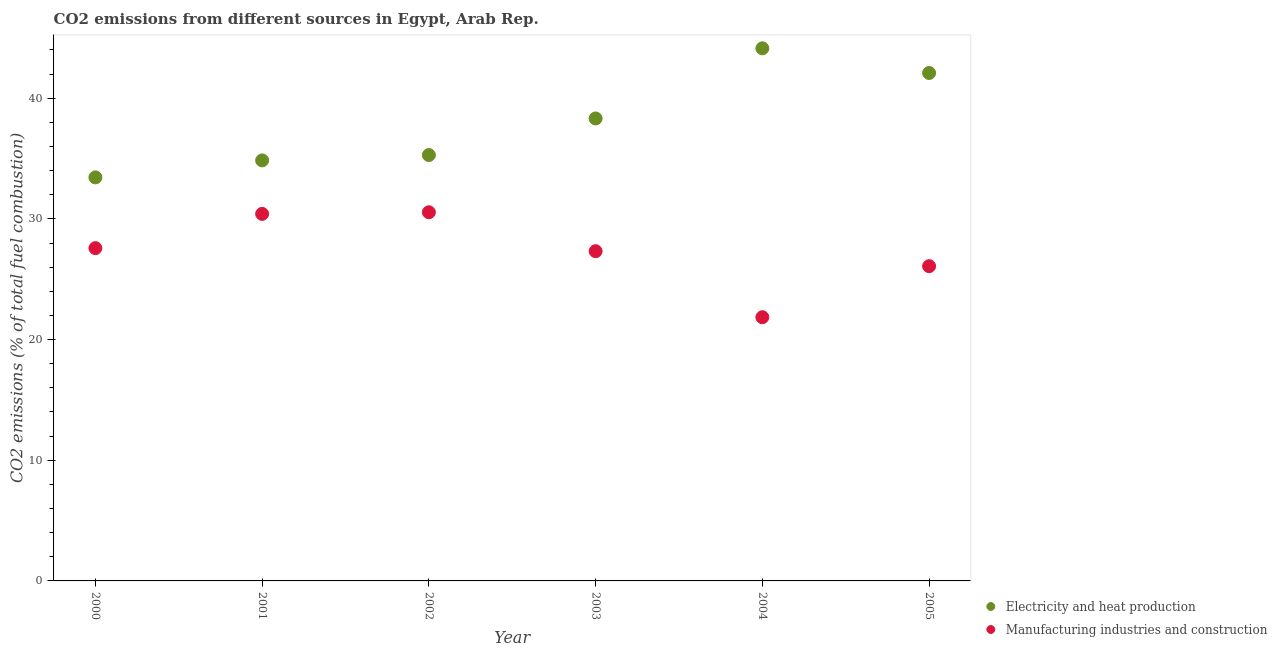Is the number of dotlines equal to the number of legend labels?
Your response must be concise. Yes. What is the co2 emissions due to manufacturing industries in 2005?
Keep it short and to the point. 26.08. Across all years, what is the maximum co2 emissions due to electricity and heat production?
Offer a terse response. 44.14. Across all years, what is the minimum co2 emissions due to electricity and heat production?
Offer a very short reply. 33.44. What is the total co2 emissions due to manufacturing industries in the graph?
Provide a succinct answer. 163.8. What is the difference between the co2 emissions due to electricity and heat production in 2000 and that in 2005?
Ensure brevity in your answer.  -8.65. What is the difference between the co2 emissions due to manufacturing industries in 2003 and the co2 emissions due to electricity and heat production in 2005?
Your response must be concise. -14.77. What is the average co2 emissions due to manufacturing industries per year?
Provide a short and direct response. 27.3. In the year 2001, what is the difference between the co2 emissions due to manufacturing industries and co2 emissions due to electricity and heat production?
Your response must be concise. -4.43. What is the ratio of the co2 emissions due to electricity and heat production in 2003 to that in 2004?
Offer a terse response. 0.87. What is the difference between the highest and the second highest co2 emissions due to manufacturing industries?
Give a very brief answer. 0.13. What is the difference between the highest and the lowest co2 emissions due to electricity and heat production?
Your response must be concise. 10.7. In how many years, is the co2 emissions due to manufacturing industries greater than the average co2 emissions due to manufacturing industries taken over all years?
Give a very brief answer. 4. Is the sum of the co2 emissions due to electricity and heat production in 2000 and 2005 greater than the maximum co2 emissions due to manufacturing industries across all years?
Provide a succinct answer. Yes. How many dotlines are there?
Your answer should be compact. 2. How many years are there in the graph?
Ensure brevity in your answer.  6. Are the values on the major ticks of Y-axis written in scientific E-notation?
Keep it short and to the point. No. What is the title of the graph?
Offer a very short reply. CO2 emissions from different sources in Egypt, Arab Rep. What is the label or title of the Y-axis?
Your answer should be compact. CO2 emissions (% of total fuel combustion). What is the CO2 emissions (% of total fuel combustion) in Electricity and heat production in 2000?
Give a very brief answer. 33.44. What is the CO2 emissions (% of total fuel combustion) of Manufacturing industries and construction in 2000?
Ensure brevity in your answer.  27.58. What is the CO2 emissions (% of total fuel combustion) of Electricity and heat production in 2001?
Your answer should be compact. 34.85. What is the CO2 emissions (% of total fuel combustion) in Manufacturing industries and construction in 2001?
Offer a very short reply. 30.42. What is the CO2 emissions (% of total fuel combustion) of Electricity and heat production in 2002?
Provide a short and direct response. 35.29. What is the CO2 emissions (% of total fuel combustion) in Manufacturing industries and construction in 2002?
Your answer should be very brief. 30.55. What is the CO2 emissions (% of total fuel combustion) in Electricity and heat production in 2003?
Give a very brief answer. 38.33. What is the CO2 emissions (% of total fuel combustion) of Manufacturing industries and construction in 2003?
Make the answer very short. 27.32. What is the CO2 emissions (% of total fuel combustion) of Electricity and heat production in 2004?
Your response must be concise. 44.14. What is the CO2 emissions (% of total fuel combustion) of Manufacturing industries and construction in 2004?
Ensure brevity in your answer.  21.85. What is the CO2 emissions (% of total fuel combustion) of Electricity and heat production in 2005?
Offer a very short reply. 42.09. What is the CO2 emissions (% of total fuel combustion) in Manufacturing industries and construction in 2005?
Your answer should be very brief. 26.08. Across all years, what is the maximum CO2 emissions (% of total fuel combustion) of Electricity and heat production?
Your response must be concise. 44.14. Across all years, what is the maximum CO2 emissions (% of total fuel combustion) in Manufacturing industries and construction?
Offer a terse response. 30.55. Across all years, what is the minimum CO2 emissions (% of total fuel combustion) of Electricity and heat production?
Ensure brevity in your answer.  33.44. Across all years, what is the minimum CO2 emissions (% of total fuel combustion) in Manufacturing industries and construction?
Your response must be concise. 21.85. What is the total CO2 emissions (% of total fuel combustion) in Electricity and heat production in the graph?
Ensure brevity in your answer.  228.14. What is the total CO2 emissions (% of total fuel combustion) in Manufacturing industries and construction in the graph?
Your response must be concise. 163.8. What is the difference between the CO2 emissions (% of total fuel combustion) in Electricity and heat production in 2000 and that in 2001?
Keep it short and to the point. -1.41. What is the difference between the CO2 emissions (% of total fuel combustion) in Manufacturing industries and construction in 2000 and that in 2001?
Offer a terse response. -2.84. What is the difference between the CO2 emissions (% of total fuel combustion) of Electricity and heat production in 2000 and that in 2002?
Your answer should be very brief. -1.85. What is the difference between the CO2 emissions (% of total fuel combustion) of Manufacturing industries and construction in 2000 and that in 2002?
Ensure brevity in your answer.  -2.97. What is the difference between the CO2 emissions (% of total fuel combustion) of Electricity and heat production in 2000 and that in 2003?
Ensure brevity in your answer.  -4.88. What is the difference between the CO2 emissions (% of total fuel combustion) of Manufacturing industries and construction in 2000 and that in 2003?
Make the answer very short. 0.25. What is the difference between the CO2 emissions (% of total fuel combustion) of Electricity and heat production in 2000 and that in 2004?
Provide a short and direct response. -10.7. What is the difference between the CO2 emissions (% of total fuel combustion) of Manufacturing industries and construction in 2000 and that in 2004?
Make the answer very short. 5.72. What is the difference between the CO2 emissions (% of total fuel combustion) of Electricity and heat production in 2000 and that in 2005?
Ensure brevity in your answer.  -8.65. What is the difference between the CO2 emissions (% of total fuel combustion) of Manufacturing industries and construction in 2000 and that in 2005?
Offer a terse response. 1.49. What is the difference between the CO2 emissions (% of total fuel combustion) of Electricity and heat production in 2001 and that in 2002?
Your answer should be very brief. -0.44. What is the difference between the CO2 emissions (% of total fuel combustion) of Manufacturing industries and construction in 2001 and that in 2002?
Give a very brief answer. -0.13. What is the difference between the CO2 emissions (% of total fuel combustion) of Electricity and heat production in 2001 and that in 2003?
Your answer should be very brief. -3.48. What is the difference between the CO2 emissions (% of total fuel combustion) in Manufacturing industries and construction in 2001 and that in 2003?
Your response must be concise. 3.09. What is the difference between the CO2 emissions (% of total fuel combustion) in Electricity and heat production in 2001 and that in 2004?
Provide a succinct answer. -9.29. What is the difference between the CO2 emissions (% of total fuel combustion) of Manufacturing industries and construction in 2001 and that in 2004?
Provide a succinct answer. 8.56. What is the difference between the CO2 emissions (% of total fuel combustion) in Electricity and heat production in 2001 and that in 2005?
Give a very brief answer. -7.24. What is the difference between the CO2 emissions (% of total fuel combustion) in Manufacturing industries and construction in 2001 and that in 2005?
Ensure brevity in your answer.  4.33. What is the difference between the CO2 emissions (% of total fuel combustion) of Electricity and heat production in 2002 and that in 2003?
Your answer should be very brief. -3.03. What is the difference between the CO2 emissions (% of total fuel combustion) in Manufacturing industries and construction in 2002 and that in 2003?
Make the answer very short. 3.23. What is the difference between the CO2 emissions (% of total fuel combustion) in Electricity and heat production in 2002 and that in 2004?
Your answer should be very brief. -8.84. What is the difference between the CO2 emissions (% of total fuel combustion) in Manufacturing industries and construction in 2002 and that in 2004?
Provide a short and direct response. 8.7. What is the difference between the CO2 emissions (% of total fuel combustion) in Electricity and heat production in 2002 and that in 2005?
Your answer should be very brief. -6.8. What is the difference between the CO2 emissions (% of total fuel combustion) of Manufacturing industries and construction in 2002 and that in 2005?
Offer a very short reply. 4.47. What is the difference between the CO2 emissions (% of total fuel combustion) of Electricity and heat production in 2003 and that in 2004?
Offer a very short reply. -5.81. What is the difference between the CO2 emissions (% of total fuel combustion) of Manufacturing industries and construction in 2003 and that in 2004?
Your answer should be compact. 5.47. What is the difference between the CO2 emissions (% of total fuel combustion) in Electricity and heat production in 2003 and that in 2005?
Your answer should be very brief. -3.77. What is the difference between the CO2 emissions (% of total fuel combustion) of Manufacturing industries and construction in 2003 and that in 2005?
Your answer should be compact. 1.24. What is the difference between the CO2 emissions (% of total fuel combustion) in Electricity and heat production in 2004 and that in 2005?
Provide a short and direct response. 2.04. What is the difference between the CO2 emissions (% of total fuel combustion) in Manufacturing industries and construction in 2004 and that in 2005?
Make the answer very short. -4.23. What is the difference between the CO2 emissions (% of total fuel combustion) of Electricity and heat production in 2000 and the CO2 emissions (% of total fuel combustion) of Manufacturing industries and construction in 2001?
Provide a short and direct response. 3.02. What is the difference between the CO2 emissions (% of total fuel combustion) of Electricity and heat production in 2000 and the CO2 emissions (% of total fuel combustion) of Manufacturing industries and construction in 2002?
Offer a terse response. 2.89. What is the difference between the CO2 emissions (% of total fuel combustion) of Electricity and heat production in 2000 and the CO2 emissions (% of total fuel combustion) of Manufacturing industries and construction in 2003?
Your answer should be very brief. 6.12. What is the difference between the CO2 emissions (% of total fuel combustion) of Electricity and heat production in 2000 and the CO2 emissions (% of total fuel combustion) of Manufacturing industries and construction in 2004?
Provide a succinct answer. 11.59. What is the difference between the CO2 emissions (% of total fuel combustion) of Electricity and heat production in 2000 and the CO2 emissions (% of total fuel combustion) of Manufacturing industries and construction in 2005?
Offer a very short reply. 7.36. What is the difference between the CO2 emissions (% of total fuel combustion) in Electricity and heat production in 2001 and the CO2 emissions (% of total fuel combustion) in Manufacturing industries and construction in 2002?
Ensure brevity in your answer.  4.3. What is the difference between the CO2 emissions (% of total fuel combustion) in Electricity and heat production in 2001 and the CO2 emissions (% of total fuel combustion) in Manufacturing industries and construction in 2003?
Give a very brief answer. 7.53. What is the difference between the CO2 emissions (% of total fuel combustion) in Electricity and heat production in 2001 and the CO2 emissions (% of total fuel combustion) in Manufacturing industries and construction in 2004?
Provide a succinct answer. 13. What is the difference between the CO2 emissions (% of total fuel combustion) of Electricity and heat production in 2001 and the CO2 emissions (% of total fuel combustion) of Manufacturing industries and construction in 2005?
Your answer should be very brief. 8.77. What is the difference between the CO2 emissions (% of total fuel combustion) of Electricity and heat production in 2002 and the CO2 emissions (% of total fuel combustion) of Manufacturing industries and construction in 2003?
Make the answer very short. 7.97. What is the difference between the CO2 emissions (% of total fuel combustion) of Electricity and heat production in 2002 and the CO2 emissions (% of total fuel combustion) of Manufacturing industries and construction in 2004?
Offer a very short reply. 13.44. What is the difference between the CO2 emissions (% of total fuel combustion) in Electricity and heat production in 2002 and the CO2 emissions (% of total fuel combustion) in Manufacturing industries and construction in 2005?
Provide a succinct answer. 9.21. What is the difference between the CO2 emissions (% of total fuel combustion) of Electricity and heat production in 2003 and the CO2 emissions (% of total fuel combustion) of Manufacturing industries and construction in 2004?
Offer a terse response. 16.47. What is the difference between the CO2 emissions (% of total fuel combustion) in Electricity and heat production in 2003 and the CO2 emissions (% of total fuel combustion) in Manufacturing industries and construction in 2005?
Your answer should be very brief. 12.24. What is the difference between the CO2 emissions (% of total fuel combustion) of Electricity and heat production in 2004 and the CO2 emissions (% of total fuel combustion) of Manufacturing industries and construction in 2005?
Keep it short and to the point. 18.05. What is the average CO2 emissions (% of total fuel combustion) in Electricity and heat production per year?
Give a very brief answer. 38.02. What is the average CO2 emissions (% of total fuel combustion) of Manufacturing industries and construction per year?
Ensure brevity in your answer.  27.3. In the year 2000, what is the difference between the CO2 emissions (% of total fuel combustion) of Electricity and heat production and CO2 emissions (% of total fuel combustion) of Manufacturing industries and construction?
Offer a terse response. 5.86. In the year 2001, what is the difference between the CO2 emissions (% of total fuel combustion) in Electricity and heat production and CO2 emissions (% of total fuel combustion) in Manufacturing industries and construction?
Ensure brevity in your answer.  4.43. In the year 2002, what is the difference between the CO2 emissions (% of total fuel combustion) in Electricity and heat production and CO2 emissions (% of total fuel combustion) in Manufacturing industries and construction?
Provide a succinct answer. 4.74. In the year 2003, what is the difference between the CO2 emissions (% of total fuel combustion) of Electricity and heat production and CO2 emissions (% of total fuel combustion) of Manufacturing industries and construction?
Give a very brief answer. 11. In the year 2004, what is the difference between the CO2 emissions (% of total fuel combustion) of Electricity and heat production and CO2 emissions (% of total fuel combustion) of Manufacturing industries and construction?
Provide a succinct answer. 22.28. In the year 2005, what is the difference between the CO2 emissions (% of total fuel combustion) in Electricity and heat production and CO2 emissions (% of total fuel combustion) in Manufacturing industries and construction?
Provide a succinct answer. 16.01. What is the ratio of the CO2 emissions (% of total fuel combustion) of Electricity and heat production in 2000 to that in 2001?
Provide a succinct answer. 0.96. What is the ratio of the CO2 emissions (% of total fuel combustion) in Manufacturing industries and construction in 2000 to that in 2001?
Give a very brief answer. 0.91. What is the ratio of the CO2 emissions (% of total fuel combustion) of Electricity and heat production in 2000 to that in 2002?
Offer a very short reply. 0.95. What is the ratio of the CO2 emissions (% of total fuel combustion) of Manufacturing industries and construction in 2000 to that in 2002?
Give a very brief answer. 0.9. What is the ratio of the CO2 emissions (% of total fuel combustion) in Electricity and heat production in 2000 to that in 2003?
Offer a very short reply. 0.87. What is the ratio of the CO2 emissions (% of total fuel combustion) of Manufacturing industries and construction in 2000 to that in 2003?
Ensure brevity in your answer.  1.01. What is the ratio of the CO2 emissions (% of total fuel combustion) in Electricity and heat production in 2000 to that in 2004?
Your answer should be compact. 0.76. What is the ratio of the CO2 emissions (% of total fuel combustion) in Manufacturing industries and construction in 2000 to that in 2004?
Make the answer very short. 1.26. What is the ratio of the CO2 emissions (% of total fuel combustion) in Electricity and heat production in 2000 to that in 2005?
Provide a succinct answer. 0.79. What is the ratio of the CO2 emissions (% of total fuel combustion) in Manufacturing industries and construction in 2000 to that in 2005?
Make the answer very short. 1.06. What is the ratio of the CO2 emissions (% of total fuel combustion) in Electricity and heat production in 2001 to that in 2002?
Ensure brevity in your answer.  0.99. What is the ratio of the CO2 emissions (% of total fuel combustion) in Manufacturing industries and construction in 2001 to that in 2002?
Make the answer very short. 1. What is the ratio of the CO2 emissions (% of total fuel combustion) of Electricity and heat production in 2001 to that in 2003?
Your response must be concise. 0.91. What is the ratio of the CO2 emissions (% of total fuel combustion) in Manufacturing industries and construction in 2001 to that in 2003?
Keep it short and to the point. 1.11. What is the ratio of the CO2 emissions (% of total fuel combustion) in Electricity and heat production in 2001 to that in 2004?
Provide a short and direct response. 0.79. What is the ratio of the CO2 emissions (% of total fuel combustion) of Manufacturing industries and construction in 2001 to that in 2004?
Offer a terse response. 1.39. What is the ratio of the CO2 emissions (% of total fuel combustion) in Electricity and heat production in 2001 to that in 2005?
Ensure brevity in your answer.  0.83. What is the ratio of the CO2 emissions (% of total fuel combustion) in Manufacturing industries and construction in 2001 to that in 2005?
Your answer should be very brief. 1.17. What is the ratio of the CO2 emissions (% of total fuel combustion) in Electricity and heat production in 2002 to that in 2003?
Offer a terse response. 0.92. What is the ratio of the CO2 emissions (% of total fuel combustion) of Manufacturing industries and construction in 2002 to that in 2003?
Your answer should be compact. 1.12. What is the ratio of the CO2 emissions (% of total fuel combustion) in Electricity and heat production in 2002 to that in 2004?
Offer a terse response. 0.8. What is the ratio of the CO2 emissions (% of total fuel combustion) of Manufacturing industries and construction in 2002 to that in 2004?
Give a very brief answer. 1.4. What is the ratio of the CO2 emissions (% of total fuel combustion) in Electricity and heat production in 2002 to that in 2005?
Provide a short and direct response. 0.84. What is the ratio of the CO2 emissions (% of total fuel combustion) of Manufacturing industries and construction in 2002 to that in 2005?
Provide a succinct answer. 1.17. What is the ratio of the CO2 emissions (% of total fuel combustion) in Electricity and heat production in 2003 to that in 2004?
Your answer should be very brief. 0.87. What is the ratio of the CO2 emissions (% of total fuel combustion) in Manufacturing industries and construction in 2003 to that in 2004?
Your answer should be very brief. 1.25. What is the ratio of the CO2 emissions (% of total fuel combustion) in Electricity and heat production in 2003 to that in 2005?
Ensure brevity in your answer.  0.91. What is the ratio of the CO2 emissions (% of total fuel combustion) in Manufacturing industries and construction in 2003 to that in 2005?
Offer a very short reply. 1.05. What is the ratio of the CO2 emissions (% of total fuel combustion) in Electricity and heat production in 2004 to that in 2005?
Your answer should be compact. 1.05. What is the ratio of the CO2 emissions (% of total fuel combustion) of Manufacturing industries and construction in 2004 to that in 2005?
Offer a terse response. 0.84. What is the difference between the highest and the second highest CO2 emissions (% of total fuel combustion) of Electricity and heat production?
Your response must be concise. 2.04. What is the difference between the highest and the second highest CO2 emissions (% of total fuel combustion) in Manufacturing industries and construction?
Give a very brief answer. 0.13. What is the difference between the highest and the lowest CO2 emissions (% of total fuel combustion) of Electricity and heat production?
Your response must be concise. 10.7. What is the difference between the highest and the lowest CO2 emissions (% of total fuel combustion) in Manufacturing industries and construction?
Keep it short and to the point. 8.7. 